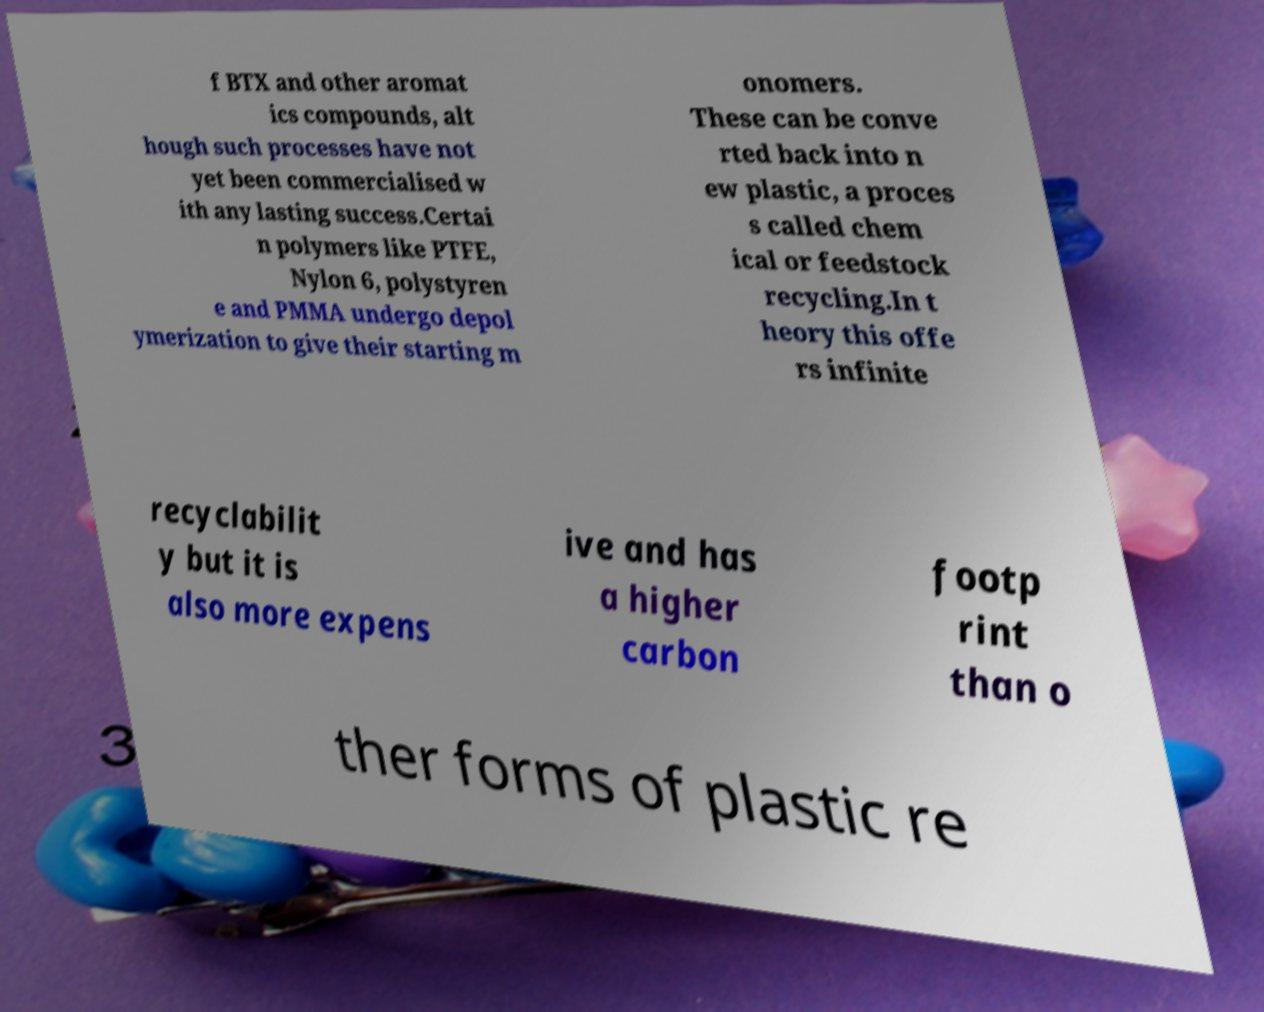I need the written content from this picture converted into text. Can you do that? f BTX and other aromat ics compounds, alt hough such processes have not yet been commercialised w ith any lasting success.Certai n polymers like PTFE, Nylon 6, polystyren e and PMMA undergo depol ymerization to give their starting m onomers. These can be conve rted back into n ew plastic, a proces s called chem ical or feedstock recycling.In t heory this offe rs infinite recyclabilit y but it is also more expens ive and has a higher carbon footp rint than o ther forms of plastic re 